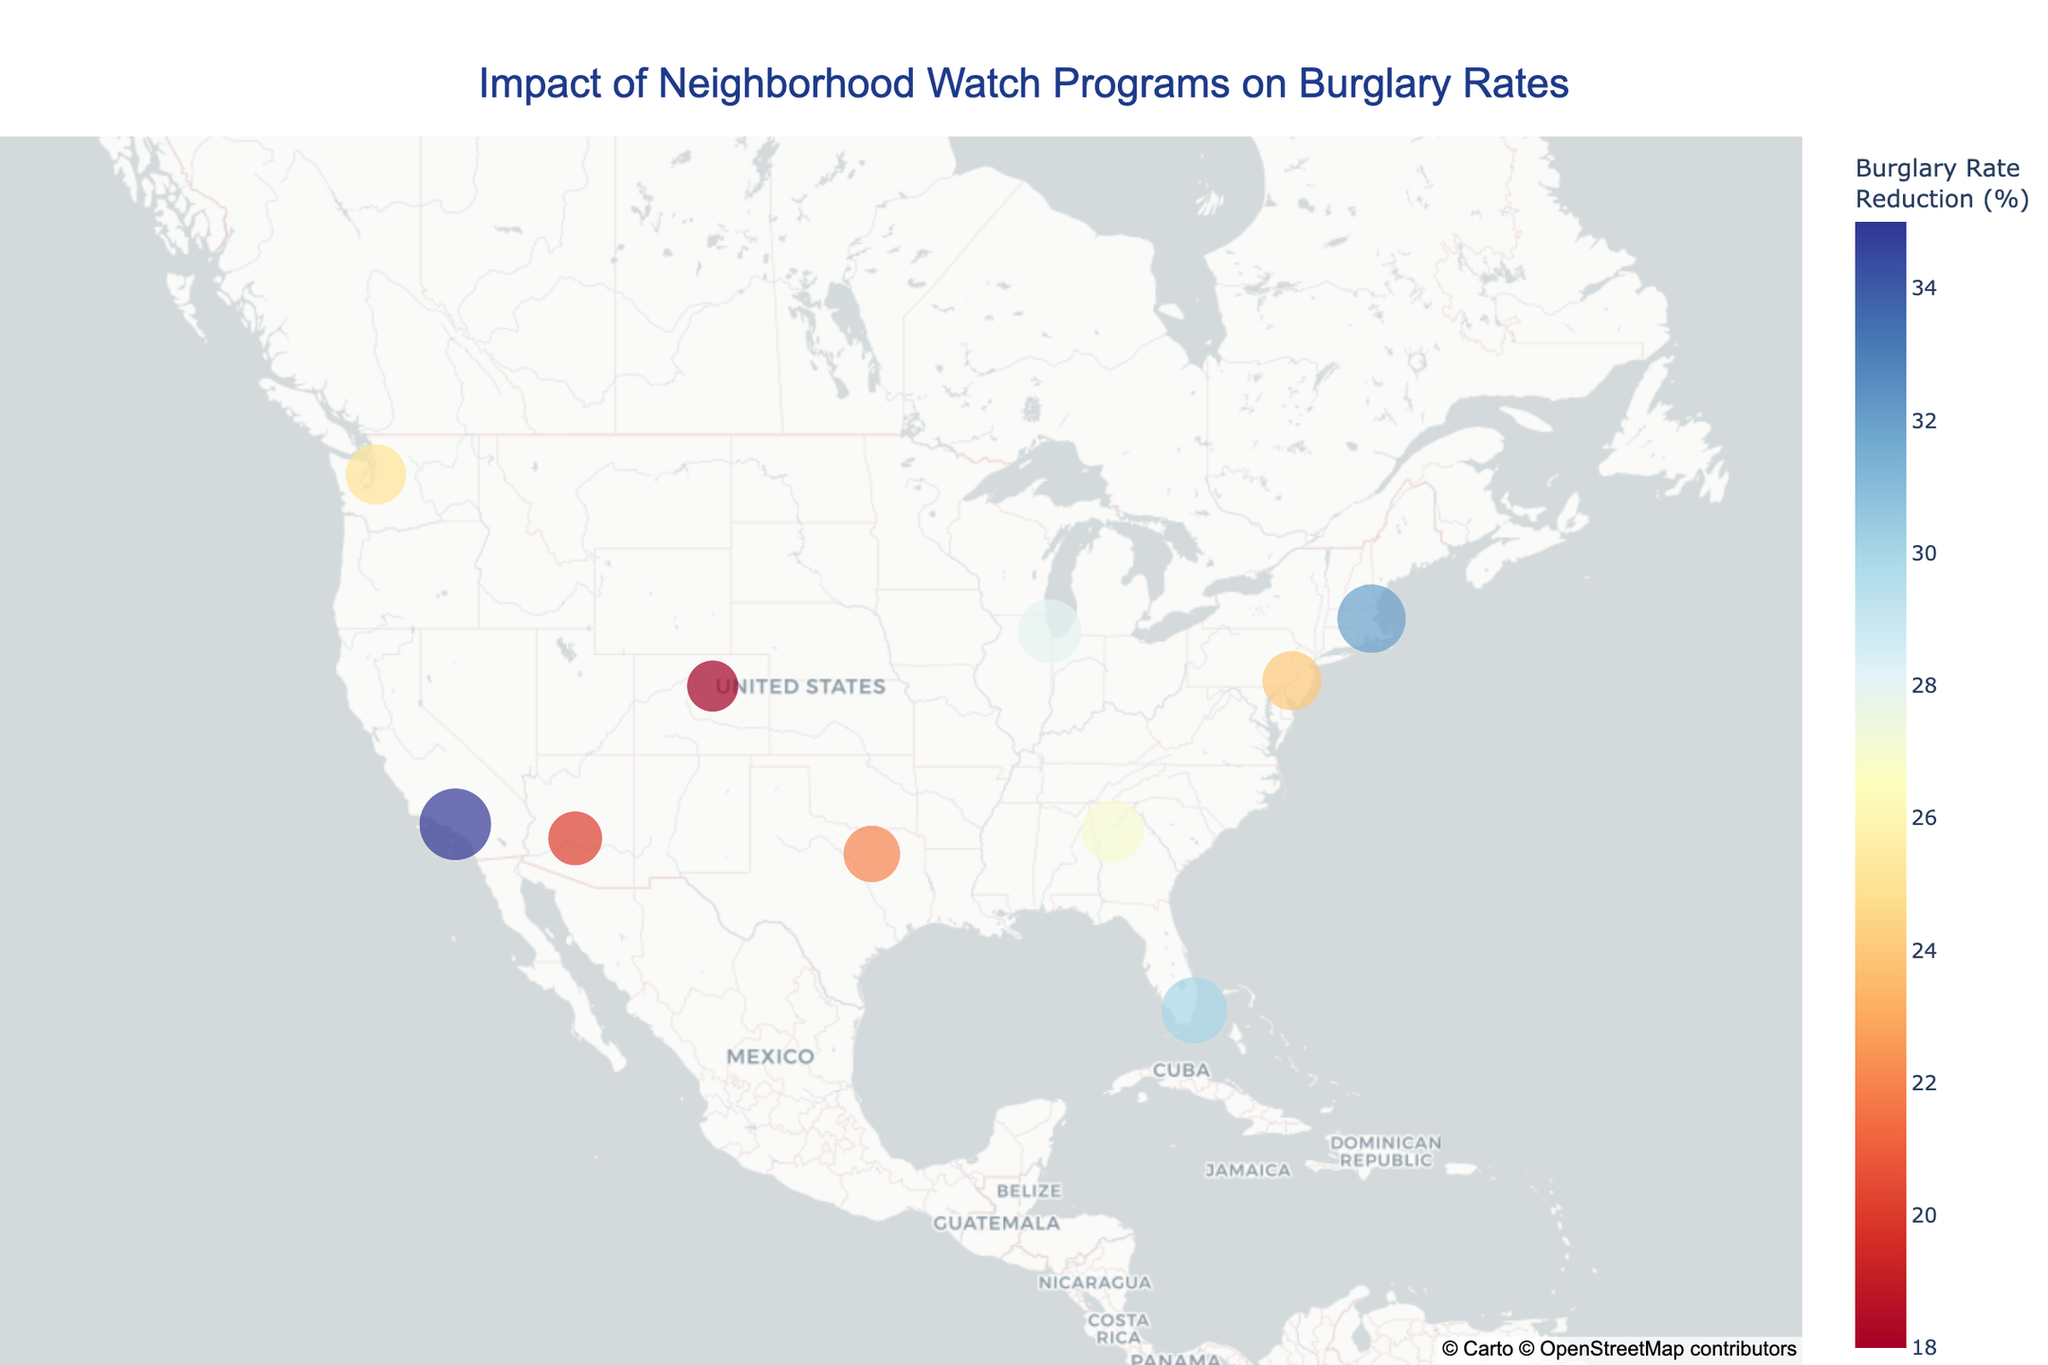How many neighborhood watch programs are shown on the map? Count the total number of data points (circles) on the map.
Answer: 10 Which neighborhood watch program has the highest burglary rate reduction? Identify the largest circle and refer to the size legend to determine the corresponding burglary rate reduction. Look for the highest value.
Answer: LA Neighborhood Watch What is the average burglary rate reduction of all programs shown? Sum the burglary rate reduction values for all programs and divide by the number of programs (32 + 28 + 35 + 30 + 25 + 22 + 18 + 27 + 20 + 24) / 10.
Answer: 26.1 Which cities have a burglary rate reduction greater than 30%? Identify the cities with circles larger than the majority and refer to the hover data to confirm burglary rate reduction greater than 30%.
Answer: Boston, Los Angeles, Miami Between Seattle and Phoenix, which city has a greater impact on burglary rate reduction? Compare the burglary rate reduction values of Seattle and Phoenix by examining their respective data points.
Answer: Seattle What is the burglary rate reduction for the program in Philadelphia? Locate the circle corresponding to Philadelphia and refer to the hover data or the color intensity for the exact reduction value.
Answer: 24% How does the reduction in burglary rates in Denver compare to Dallas? Compare the burglary rate reduction values for Denver and Dallas by examining their respective circles and hover data.
Answer: Less in Denver What is the median burglary rate reduction across all neighborhood watch programs? List out the burglary rate reductions (18, 20, 22, 24, 25, 27, 28, 30, 32, 35). The median is the middle value, here (27 + 28) / 2 since there are 10 values.
Answer: 27.5 Which region (North, South, East, West) of the United States shows the highest average reduction in burglary rates? Group the cities by regions (e.g., North: Boston, Chicago; South: Miami, Dallas, Atlanta; East: Philadelphia; West: Los Angeles, Seattle, Denver, Phoenix), calculate the average for each region, and compare.
Answer: West What is the smallest burglary rate reduction recorded, and which program does it belong to? Identify the smallest circle on the map and refer to the hover data to find the exact reduction and corresponding program.
Answer: 18%, Mile High Watch 